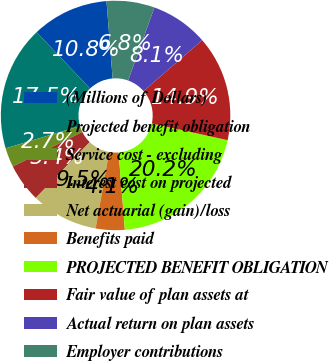Convert chart. <chart><loc_0><loc_0><loc_500><loc_500><pie_chart><fcel>(Millions of Dollars)<fcel>Projected benefit obligation<fcel>Service cost - excluding<fcel>Interest cost on projected<fcel>Net actuarial (gain)/loss<fcel>Benefits paid<fcel>PROJECTED BENEFIT OBLIGATION<fcel>Fair value of plan assets at<fcel>Actual return on plan assets<fcel>Employer contributions<nl><fcel>10.81%<fcel>17.55%<fcel>2.72%<fcel>5.42%<fcel>9.46%<fcel>4.07%<fcel>20.25%<fcel>14.85%<fcel>8.11%<fcel>6.76%<nl></chart> 